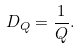Convert formula to latex. <formula><loc_0><loc_0><loc_500><loc_500>D _ { Q } = \frac { 1 } { Q } .</formula> 